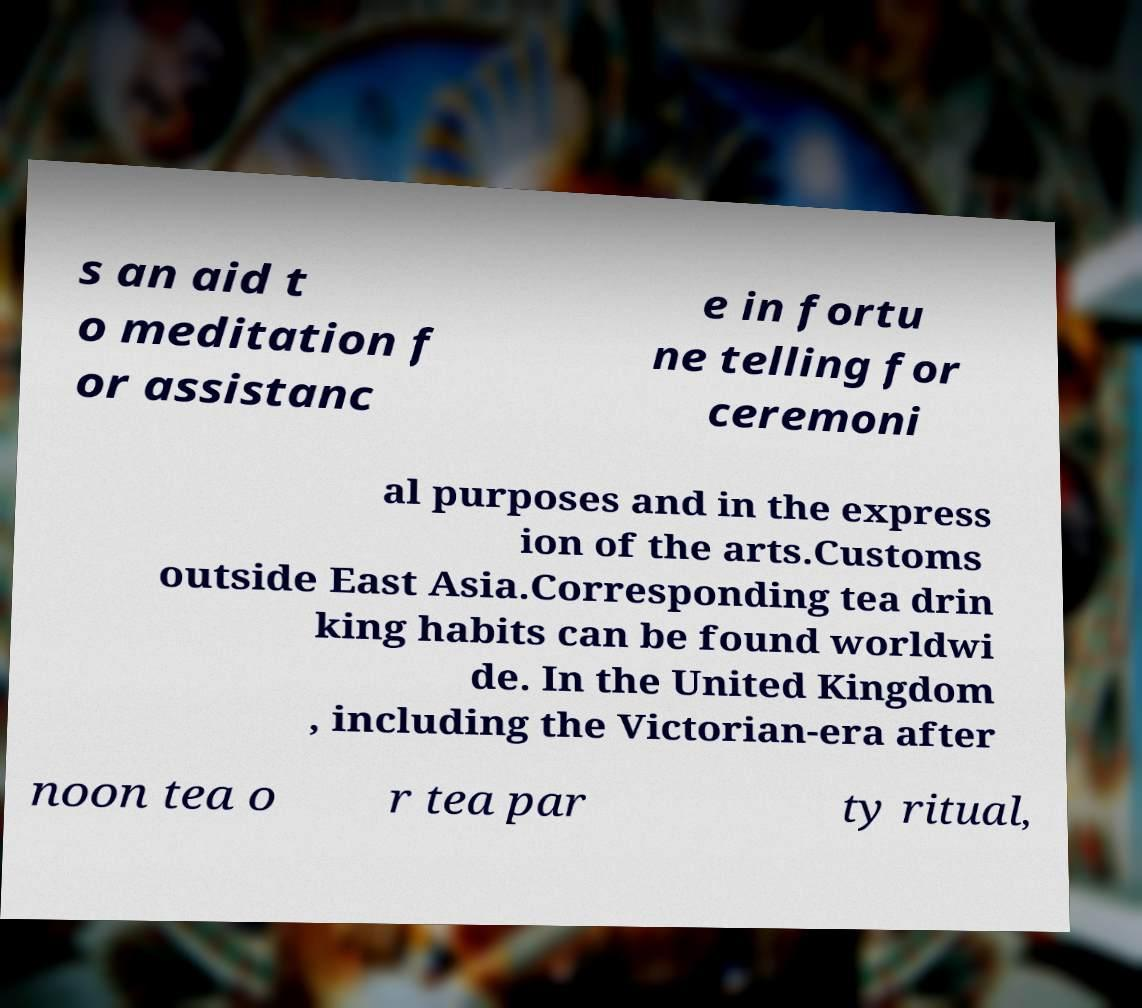For documentation purposes, I need the text within this image transcribed. Could you provide that? s an aid t o meditation f or assistanc e in fortu ne telling for ceremoni al purposes and in the express ion of the arts.Customs outside East Asia.Corresponding tea drin king habits can be found worldwi de. In the United Kingdom , including the Victorian-era after noon tea o r tea par ty ritual, 